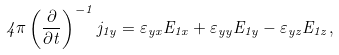<formula> <loc_0><loc_0><loc_500><loc_500>4 \pi \left ( \frac { \partial } { \partial t } \right ) ^ { - 1 } j _ { 1 y } = \varepsilon _ { y x } E _ { 1 x } + \varepsilon _ { y y } E _ { 1 y } - \varepsilon _ { y z } E _ { 1 z } ,</formula> 